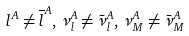<formula> <loc_0><loc_0><loc_500><loc_500>l ^ { A } \neq \overline { l } ^ { A } , \, \nu _ { l } ^ { A } \neq { \bar { \nu } _ { l } } ^ { A } , \, \nu _ { M } ^ { A } \neq { \bar { \nu } _ { M } } ^ { A }</formula> 